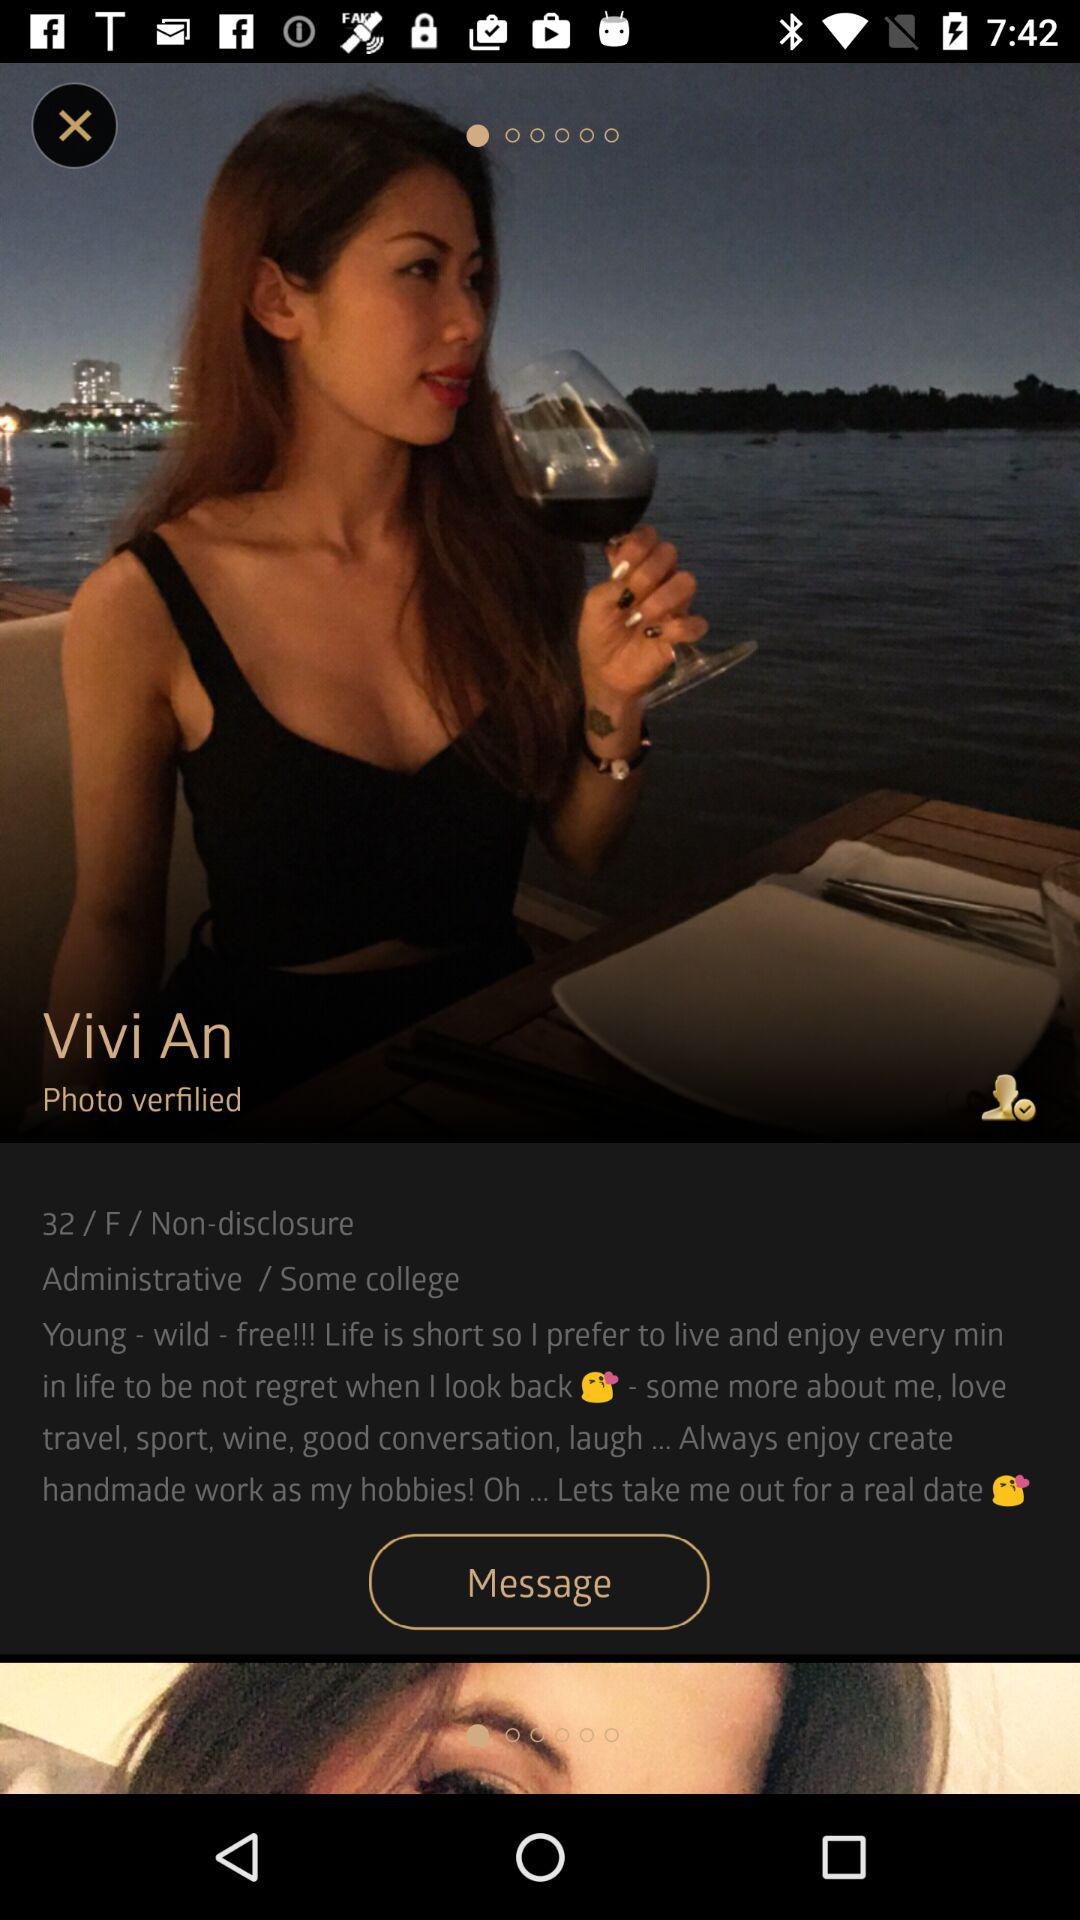What's the occupation of Vivi An? The occupation of Vivi An is administrative. 